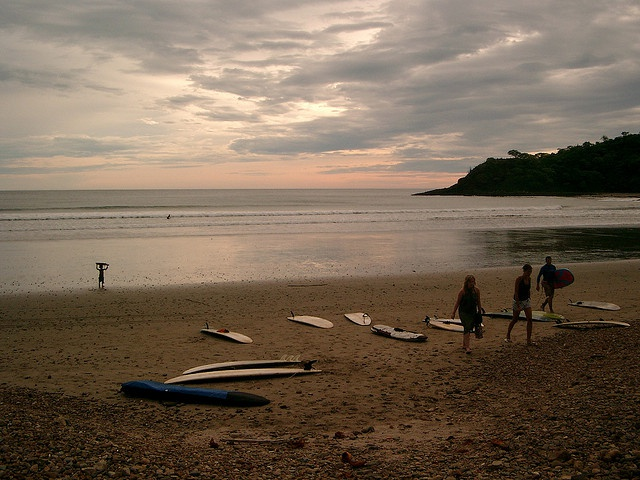Describe the objects in this image and their specific colors. I can see surfboard in gray, black, navy, and maroon tones, surfboard in gray, black, tan, and maroon tones, people in gray, black, and maroon tones, people in gray, black, and maroon tones, and people in gray and black tones in this image. 